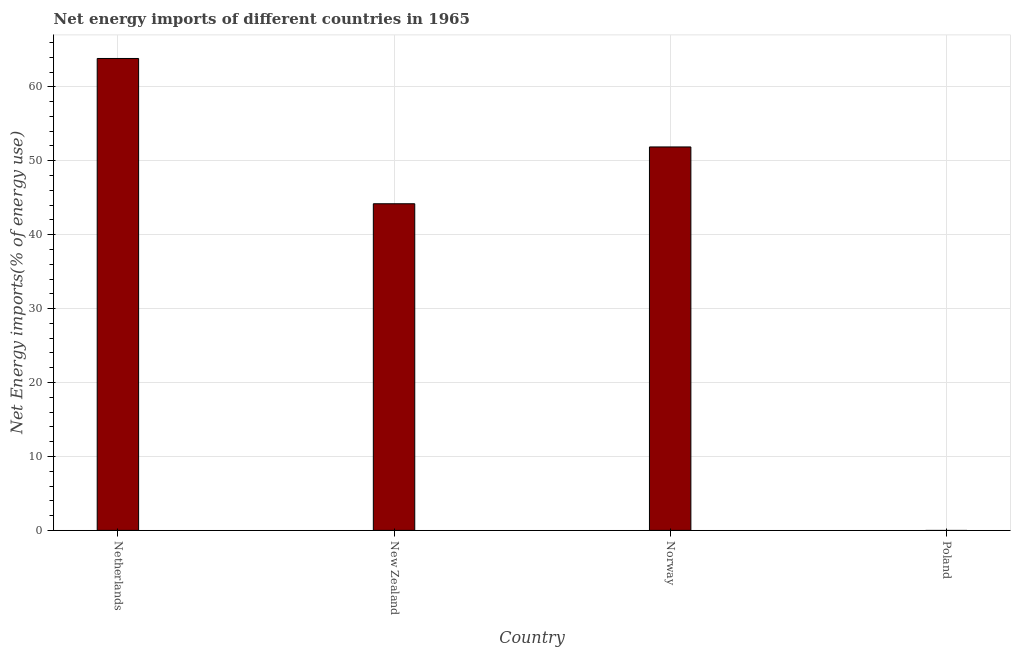What is the title of the graph?
Your answer should be very brief. Net energy imports of different countries in 1965. What is the label or title of the X-axis?
Offer a very short reply. Country. What is the label or title of the Y-axis?
Your answer should be very brief. Net Energy imports(% of energy use). What is the energy imports in New Zealand?
Keep it short and to the point. 44.18. Across all countries, what is the maximum energy imports?
Offer a very short reply. 63.84. What is the sum of the energy imports?
Provide a succinct answer. 159.89. What is the difference between the energy imports in New Zealand and Norway?
Give a very brief answer. -7.68. What is the average energy imports per country?
Your response must be concise. 39.97. What is the median energy imports?
Your answer should be compact. 48.03. In how many countries, is the energy imports greater than 16 %?
Offer a terse response. 3. What is the ratio of the energy imports in Netherlands to that in New Zealand?
Offer a very short reply. 1.45. Is the difference between the energy imports in New Zealand and Norway greater than the difference between any two countries?
Ensure brevity in your answer.  No. What is the difference between the highest and the second highest energy imports?
Offer a very short reply. 11.97. What is the difference between the highest and the lowest energy imports?
Your answer should be very brief. 63.84. How many countries are there in the graph?
Offer a very short reply. 4. What is the Net Energy imports(% of energy use) in Netherlands?
Offer a terse response. 63.84. What is the Net Energy imports(% of energy use) in New Zealand?
Your answer should be compact. 44.18. What is the Net Energy imports(% of energy use) in Norway?
Make the answer very short. 51.87. What is the Net Energy imports(% of energy use) in Poland?
Your answer should be very brief. 0. What is the difference between the Net Energy imports(% of energy use) in Netherlands and New Zealand?
Your response must be concise. 19.65. What is the difference between the Net Energy imports(% of energy use) in Netherlands and Norway?
Your answer should be very brief. 11.97. What is the difference between the Net Energy imports(% of energy use) in New Zealand and Norway?
Ensure brevity in your answer.  -7.68. What is the ratio of the Net Energy imports(% of energy use) in Netherlands to that in New Zealand?
Keep it short and to the point. 1.45. What is the ratio of the Net Energy imports(% of energy use) in Netherlands to that in Norway?
Make the answer very short. 1.23. What is the ratio of the Net Energy imports(% of energy use) in New Zealand to that in Norway?
Provide a short and direct response. 0.85. 